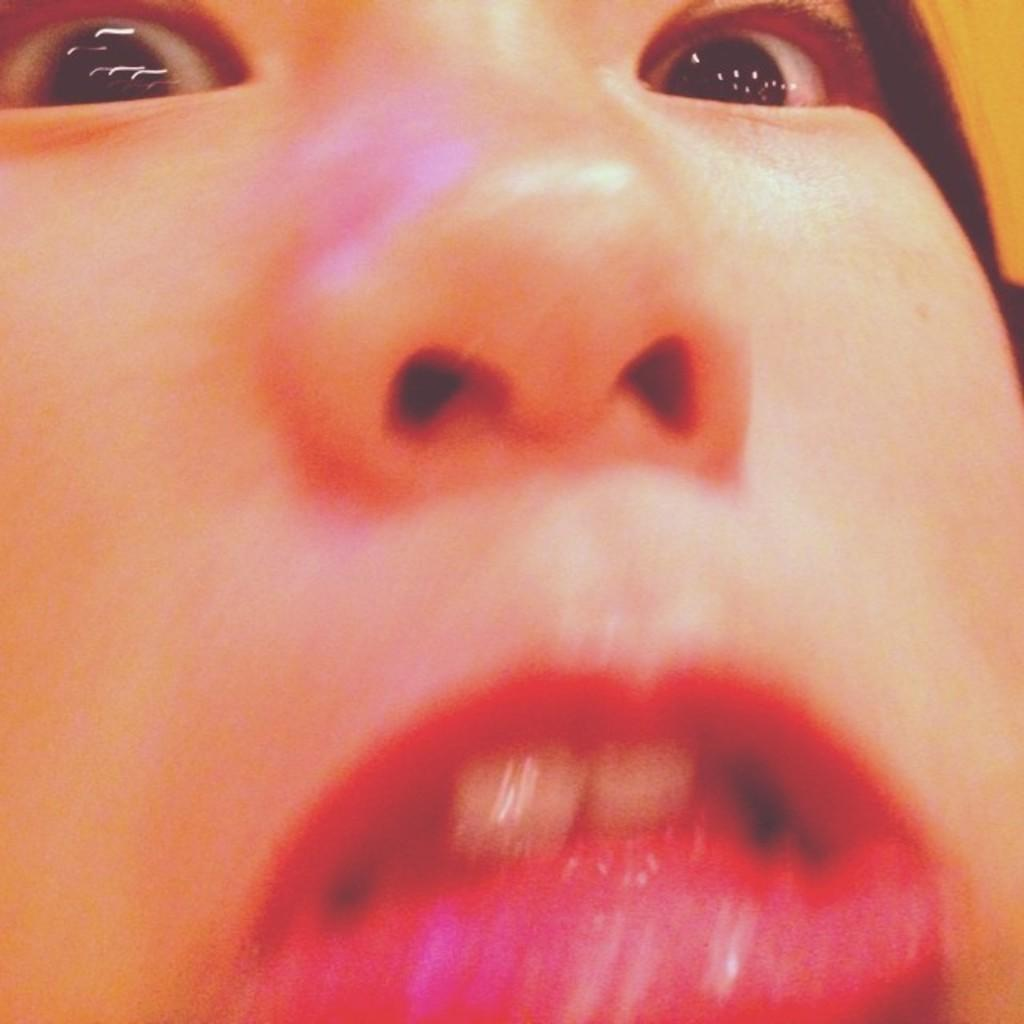What is the main subject of the image? There is a human face in the image. What are the facial features that can be seen in the image? The face has eyes, a nose, and a mouth. What type of canvas is used to create the image? There is no canvas mentioned in the facts provided, and the image does not indicate the medium used to create it. 